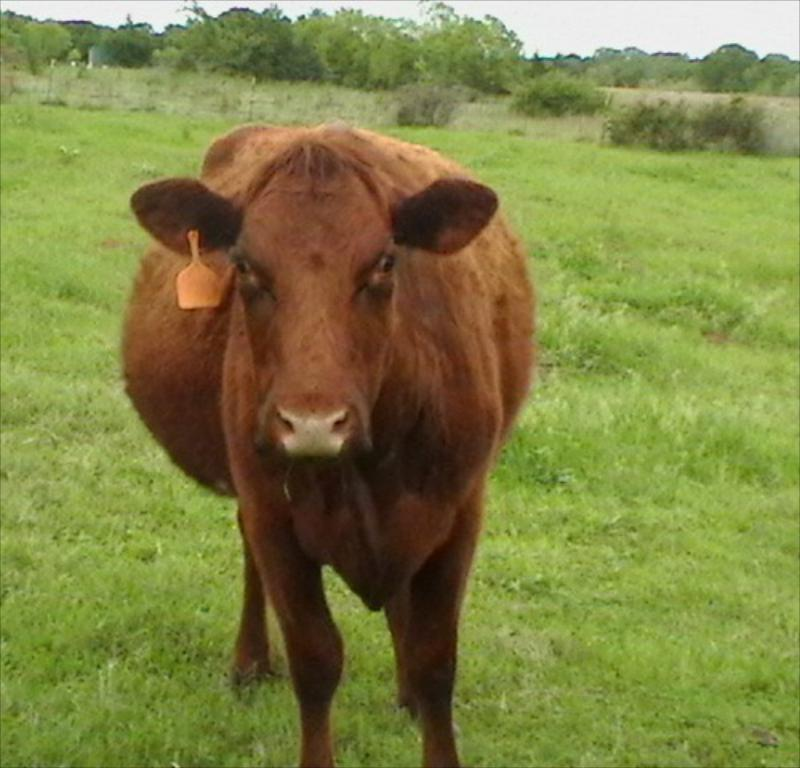What type of animal is in the image? There is a brown cow in the image. What is on the ground where the cow is standing? There is grass on the ground in the image. What can be seen in the distance behind the cow? There are trees in the background of the image. What is visible above the trees in the image? The sky is visible in the background of the image. What type of board is being traded in the image? There is no board or trade activity depicted in the image; it features a brown cow in a grassy area with trees and sky in the background. 